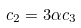Convert formula to latex. <formula><loc_0><loc_0><loc_500><loc_500>c _ { 2 } = 3 \alpha c _ { 3 }</formula> 